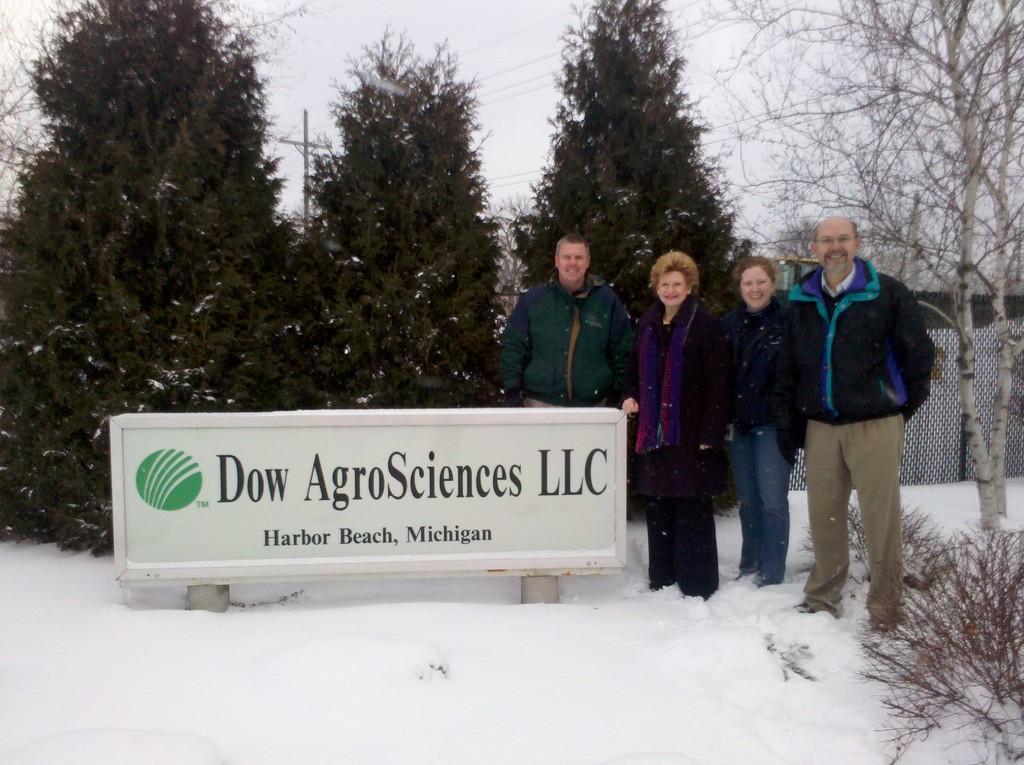In one or two sentences, can you explain what this image depicts? There are four people standing. This looks like a name board, which is attached to the poles. These are the trees and plants. This is the snow. In the background, I think this is a fence. This looks like a current pole. 